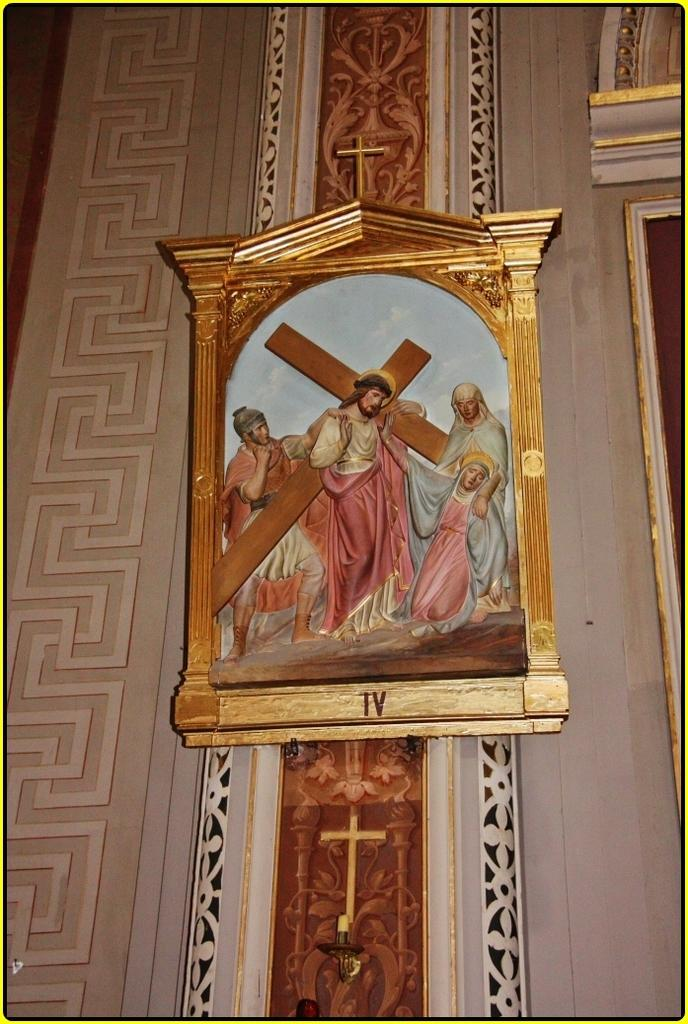<image>
Describe the image concisely. A picture of Jesus Christ carrying a cross in a frame with "IV" written on the bottom. 